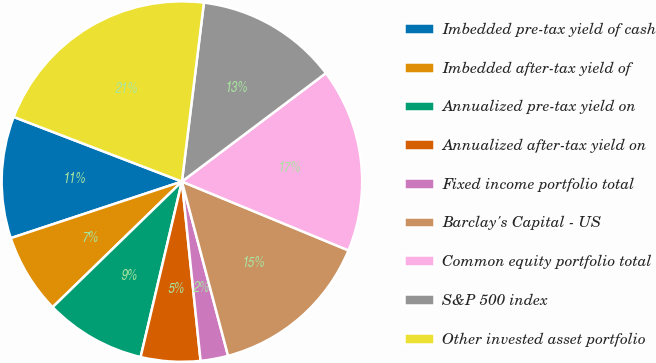Convert chart to OTSL. <chart><loc_0><loc_0><loc_500><loc_500><pie_chart><fcel>Imbedded pre-tax yield of cash<fcel>Imbedded after-tax yield of<fcel>Annualized pre-tax yield on<fcel>Annualized after-tax yield on<fcel>Fixed income portfolio total<fcel>Barclay's Capital - US<fcel>Common equity portfolio total<fcel>S&P 500 index<fcel>Other invested asset portfolio<nl><fcel>10.92%<fcel>7.19%<fcel>9.05%<fcel>5.33%<fcel>2.47%<fcel>14.64%<fcel>16.51%<fcel>12.78%<fcel>21.11%<nl></chart> 